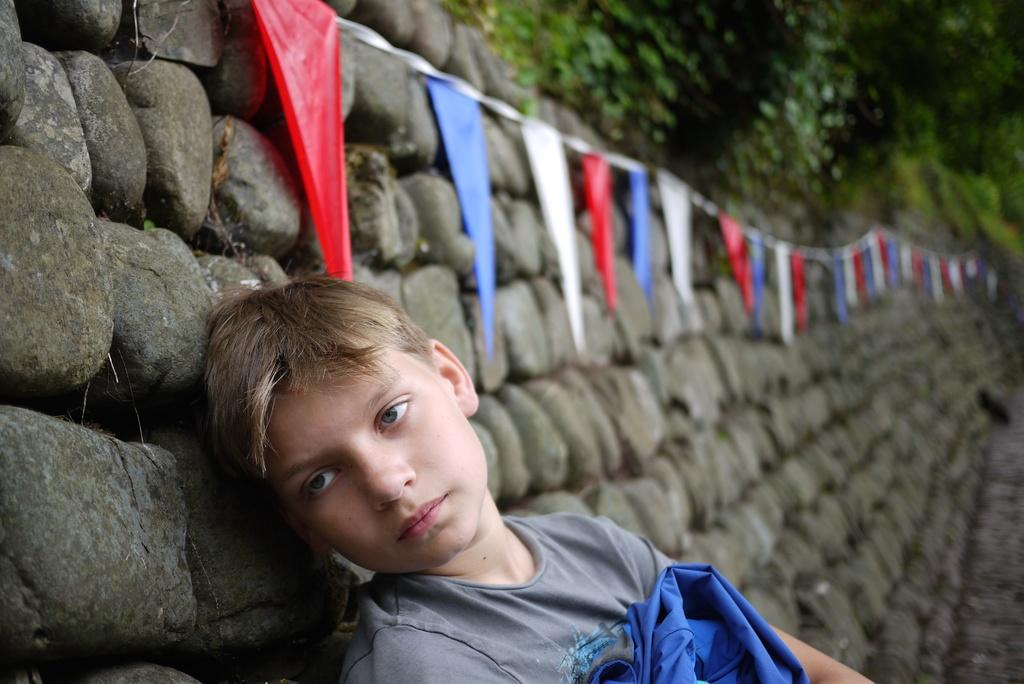Who is the main subject in the image? There is a boy in the image. What is the boy wearing? The boy is wearing a grey t-shirt. What can be seen behind the boy in the image? There is a stone wall with decorative flags behind the boy. What type of vegetation is visible at the top right of the image? There are trees visible at the top right of the image. What type of writer is depicted in the image? There is no writer present in the image; it features a boy wearing a grey t-shirt with a stone wall and trees in the background. How many forks can be seen in the image? There are no forks present in the image. 